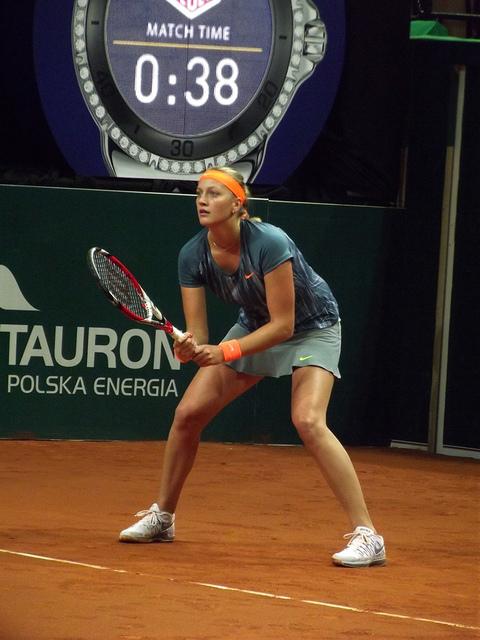What is the woman preparing to do?
Short answer required. Hit ball. What is the current match time in the picture?
Concise answer only. 0:38. What is the woman holding?
Give a very brief answer. Tennis racket. What time is it?
Give a very brief answer. 0:38. 